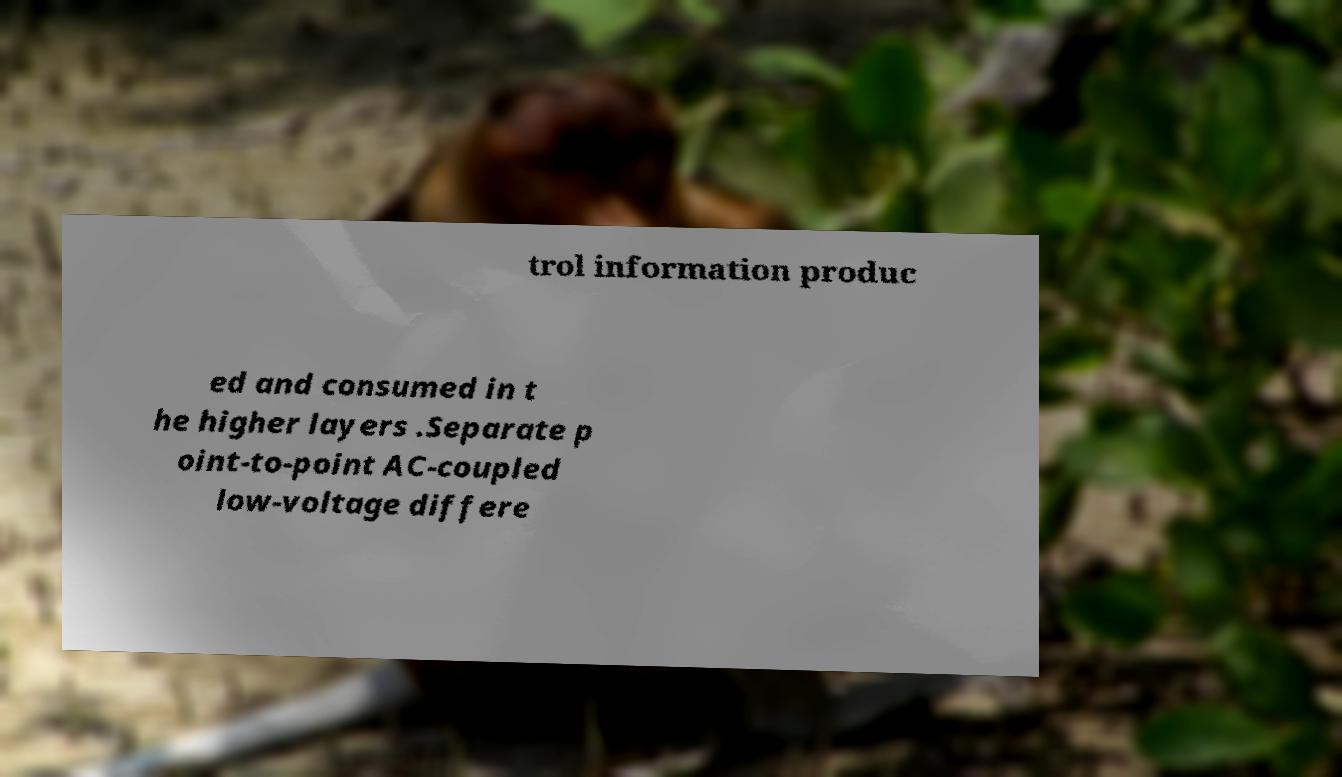Can you read and provide the text displayed in the image?This photo seems to have some interesting text. Can you extract and type it out for me? trol information produc ed and consumed in t he higher layers .Separate p oint-to-point AC-coupled low-voltage differe 